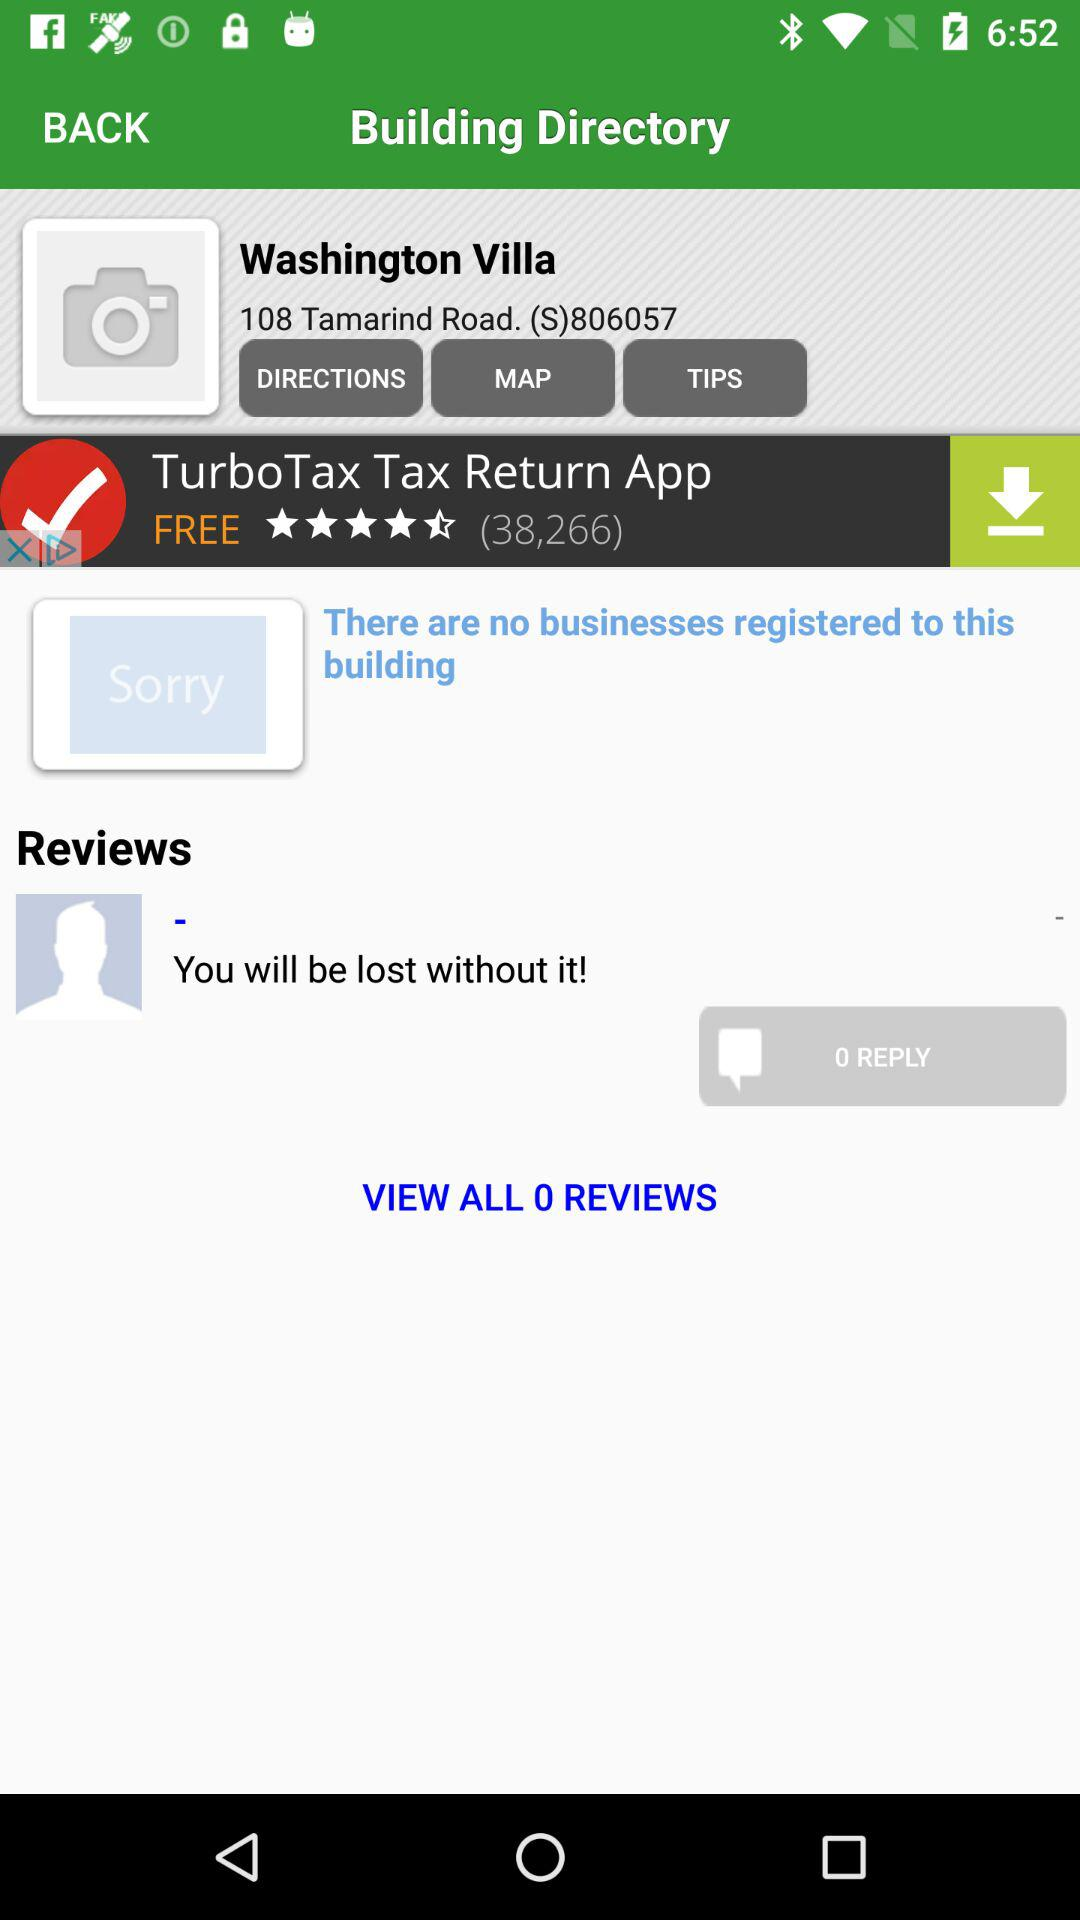How many reviews are there for the TurboTax Tax Return App?
Answer the question using a single word or phrase. 38,266 